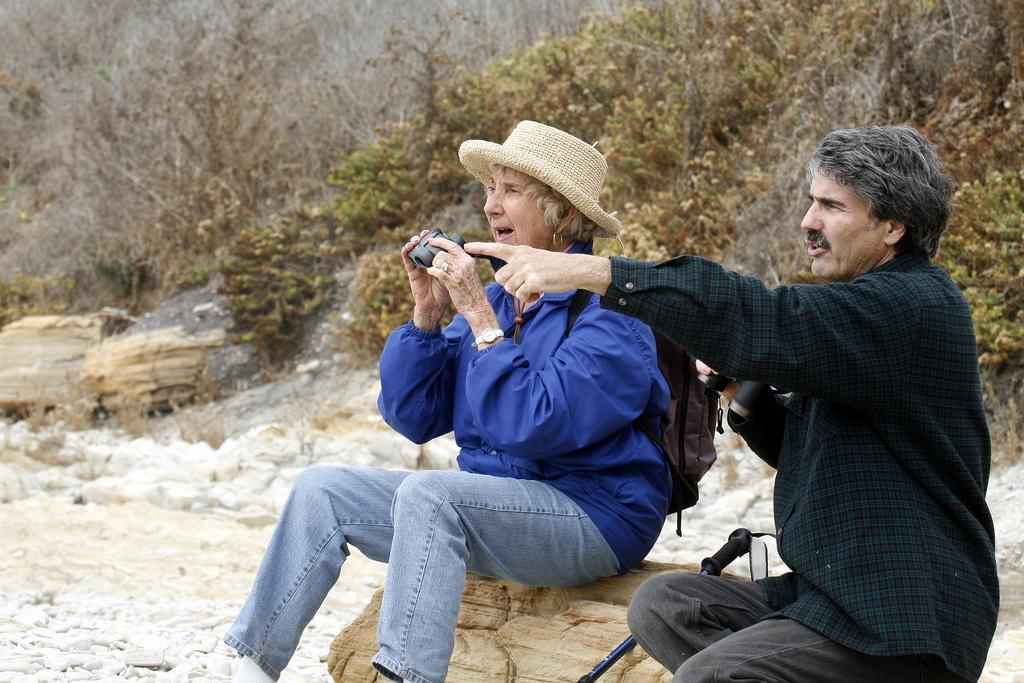How many people are in the image? There are two persons in the image. What are the persons doing in the image? The persons are sitting and holding binoculars. What can be seen in the background of the image? There is a hill and plants in the background of the image. What type of volcano can be seen in the image? There is no volcano present in the image. How do the persons show respect to each other in the image? The image does not provide information about how the persons show respect to each other. 